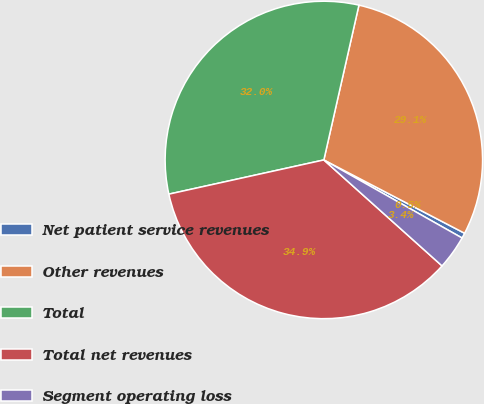Convert chart. <chart><loc_0><loc_0><loc_500><loc_500><pie_chart><fcel>Net patient service revenues<fcel>Other revenues<fcel>Total<fcel>Total net revenues<fcel>Segment operating loss<nl><fcel>0.54%<fcel>29.1%<fcel>32.01%<fcel>34.92%<fcel>3.45%<nl></chart> 